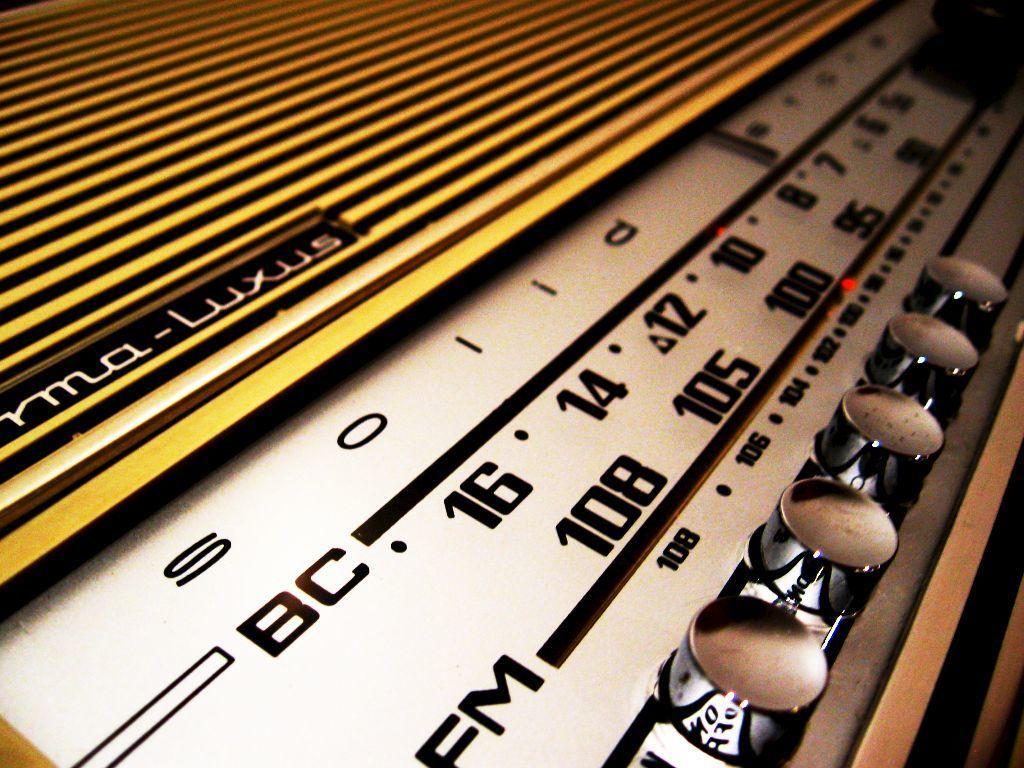Could you give a brief overview of what you see in this image? In this image I can see a radio with some text written on it. 